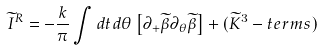<formula> <loc_0><loc_0><loc_500><loc_500>\widetilde { I } ^ { R } = - \frac { k } { \pi } \int d t d \theta \left [ \partial _ { + } \widetilde { \beta } \partial _ { \theta } \widetilde { \beta } \right ] + ( \widetilde { K } ^ { 3 } - t e r m s )</formula> 